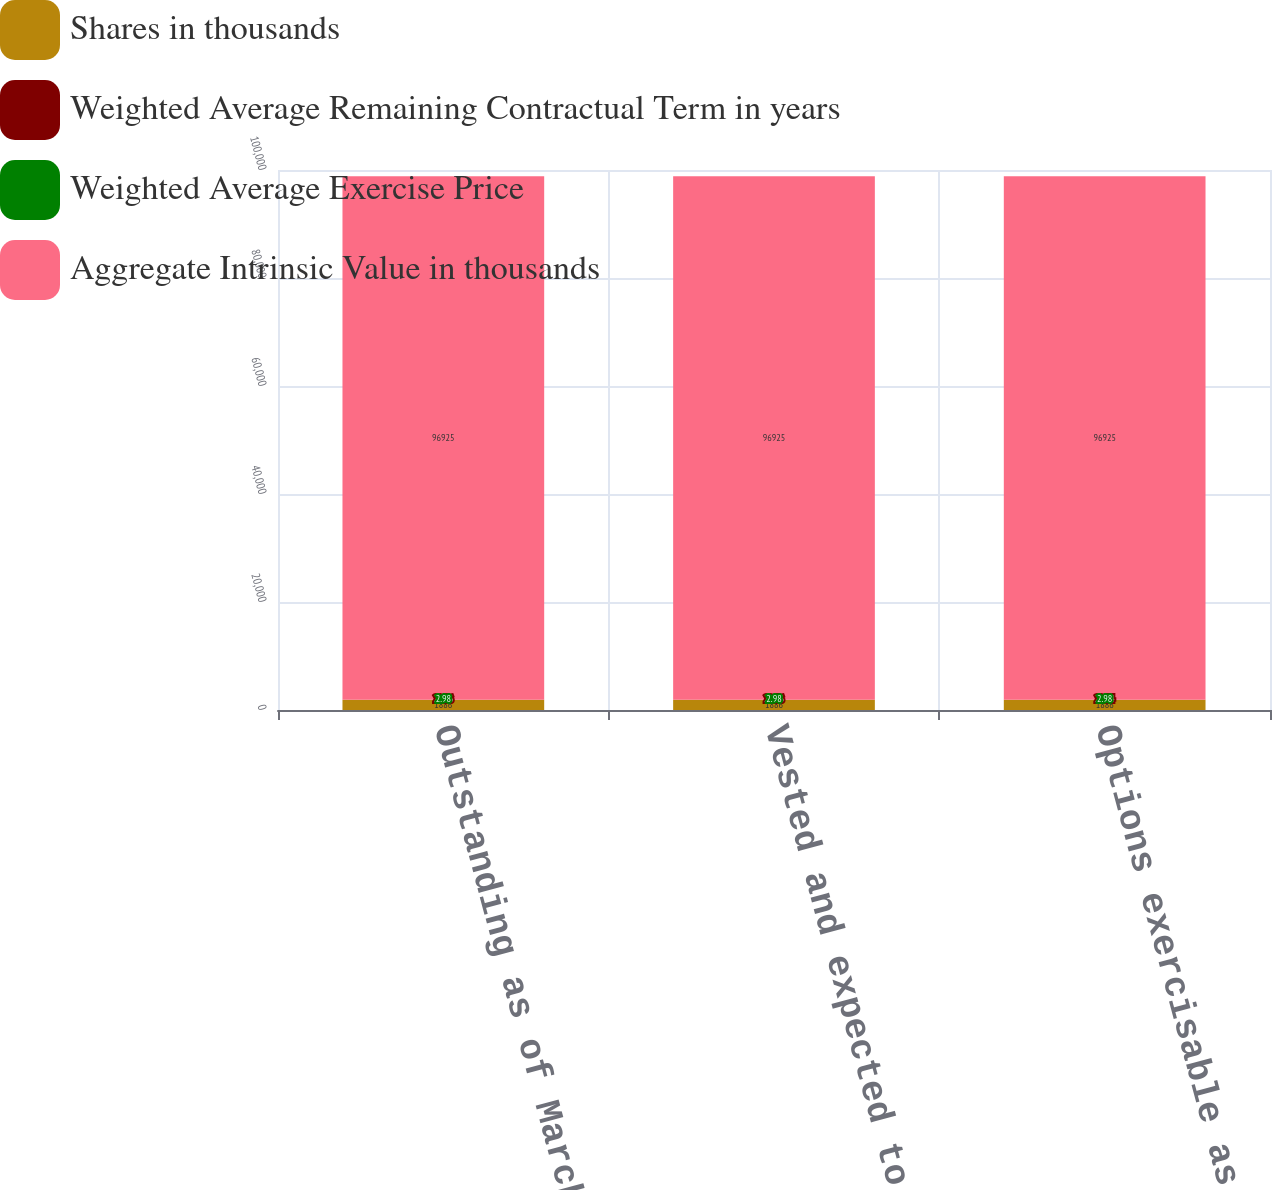Convert chart. <chart><loc_0><loc_0><loc_500><loc_500><stacked_bar_chart><ecel><fcel>Outstanding as of March 30<fcel>Vested and expected to vest as<fcel>Options exercisable as of<nl><fcel>Shares in thousands<fcel>1886<fcel>1886<fcel>1886<nl><fcel>Weighted Average Remaining Contractual Term in years<fcel>20.36<fcel>20.36<fcel>20.34<nl><fcel>Weighted Average Exercise Price<fcel>2.98<fcel>2.98<fcel>2.98<nl><fcel>Aggregate Intrinsic Value in thousands<fcel>96925<fcel>96925<fcel>96925<nl></chart> 